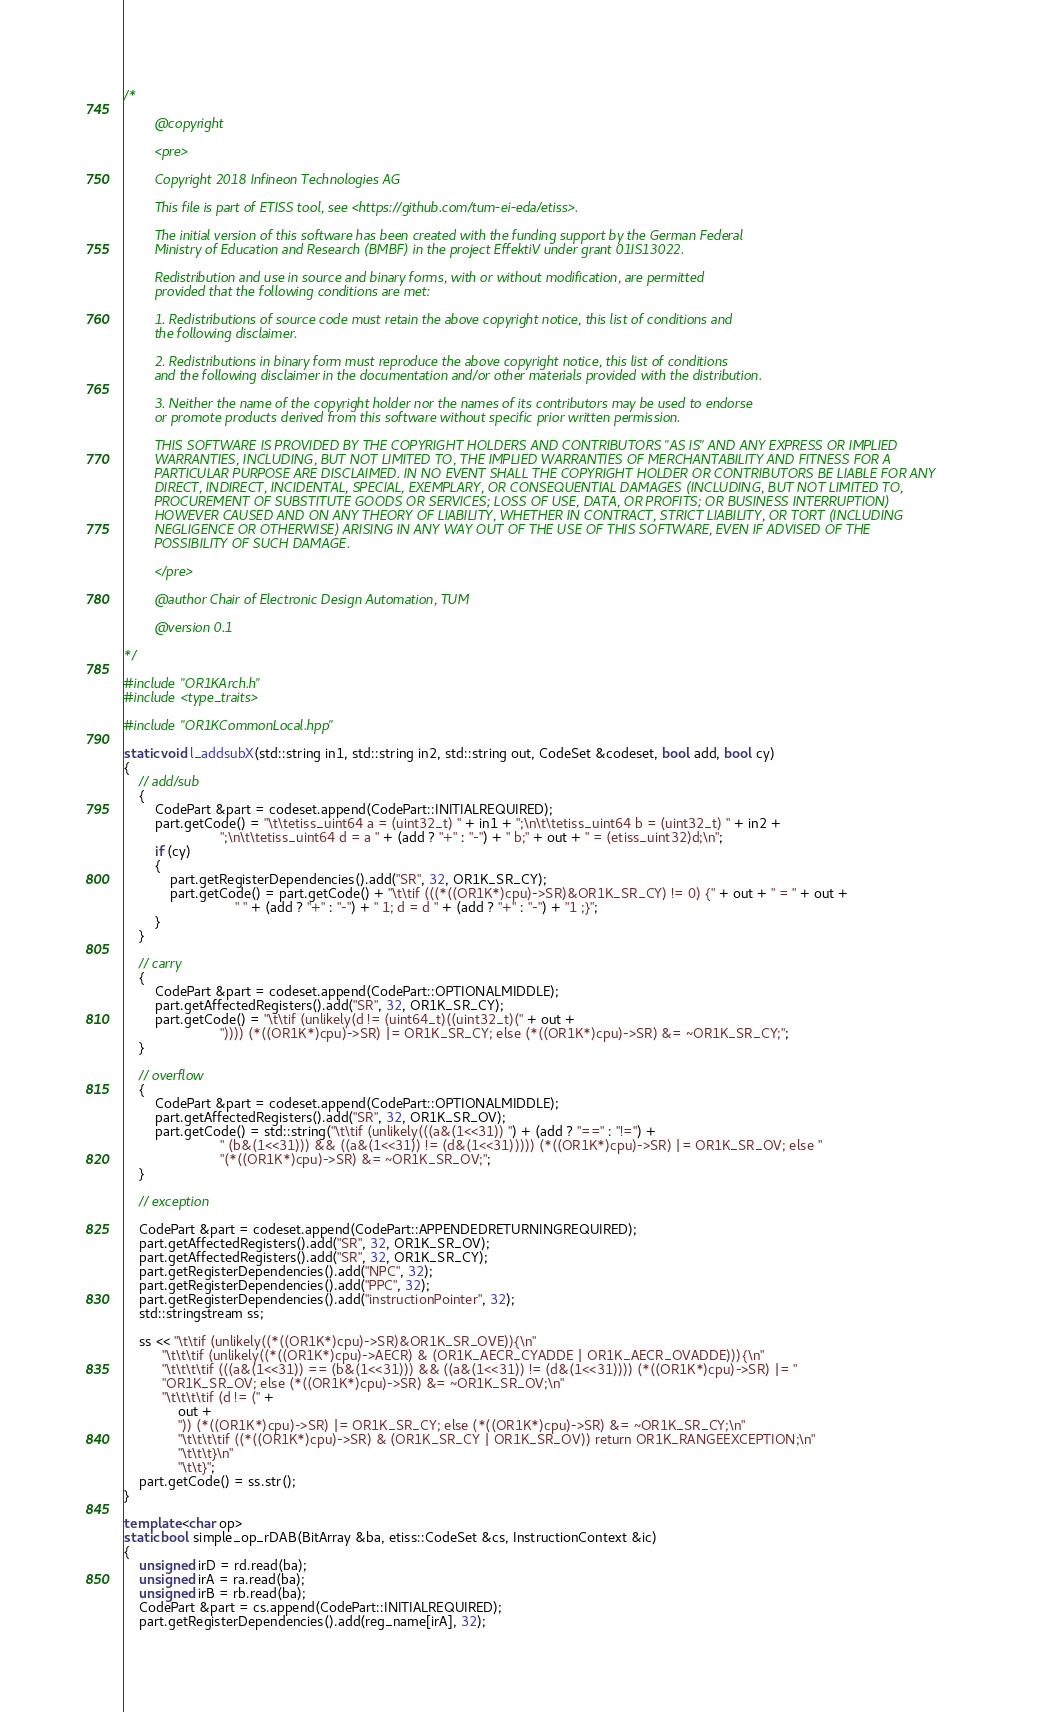Convert code to text. <code><loc_0><loc_0><loc_500><loc_500><_C++_>/*

        @copyright

        <pre>

        Copyright 2018 Infineon Technologies AG

        This file is part of ETISS tool, see <https://github.com/tum-ei-eda/etiss>.

        The initial version of this software has been created with the funding support by the German Federal
        Ministry of Education and Research (BMBF) in the project EffektiV under grant 01IS13022.

        Redistribution and use in source and binary forms, with or without modification, are permitted
        provided that the following conditions are met:

        1. Redistributions of source code must retain the above copyright notice, this list of conditions and
        the following disclaimer.

        2. Redistributions in binary form must reproduce the above copyright notice, this list of conditions
        and the following disclaimer in the documentation and/or other materials provided with the distribution.

        3. Neither the name of the copyright holder nor the names of its contributors may be used to endorse
        or promote products derived from this software without specific prior written permission.

        THIS SOFTWARE IS PROVIDED BY THE COPYRIGHT HOLDERS AND CONTRIBUTORS "AS IS" AND ANY EXPRESS OR IMPLIED
        WARRANTIES, INCLUDING, BUT NOT LIMITED TO, THE IMPLIED WARRANTIES OF MERCHANTABILITY AND FITNESS FOR A
        PARTICULAR PURPOSE ARE DISCLAIMED. IN NO EVENT SHALL THE COPYRIGHT HOLDER OR CONTRIBUTORS BE LIABLE FOR ANY
        DIRECT, INDIRECT, INCIDENTAL, SPECIAL, EXEMPLARY, OR CONSEQUENTIAL DAMAGES (INCLUDING, BUT NOT LIMITED TO,
        PROCUREMENT OF SUBSTITUTE GOODS OR SERVICES; LOSS OF USE, DATA, OR PROFITS; OR BUSINESS INTERRUPTION)
        HOWEVER CAUSED AND ON ANY THEORY OF LIABILITY, WHETHER IN CONTRACT, STRICT LIABILITY, OR TORT (INCLUDING
        NEGLIGENCE OR OTHERWISE) ARISING IN ANY WAY OUT OF THE USE OF THIS SOFTWARE, EVEN IF ADVISED OF THE
        POSSIBILITY OF SUCH DAMAGE.

        </pre>

        @author Chair of Electronic Design Automation, TUM

        @version 0.1

*/

#include "OR1KArch.h"
#include <type_traits>

#include "OR1KCommonLocal.hpp"

static void l_addsubX(std::string in1, std::string in2, std::string out, CodeSet &codeset, bool add, bool cy)
{
    // add/sub
    {
        CodePart &part = codeset.append(CodePart::INITIALREQUIRED);
        part.getCode() = "\t\tetiss_uint64 a = (uint32_t) " + in1 + ";\n\t\tetiss_uint64 b = (uint32_t) " + in2 +
                         ";\n\t\tetiss_uint64 d = a " + (add ? "+" : "-") + " b;" + out + " = (etiss_uint32)d;\n";
        if (cy)
        {
            part.getRegisterDependencies().add("SR", 32, OR1K_SR_CY);
            part.getCode() = part.getCode() + "\t\tif (((*((OR1K*)cpu)->SR)&OR1K_SR_CY) != 0) {" + out + " = " + out +
                             " " + (add ? "+" : "-") + " 1; d = d " + (add ? "+" : "-") + "1 ;}";
        }
    }

    // carry
    {
        CodePart &part = codeset.append(CodePart::OPTIONALMIDDLE);
        part.getAffectedRegisters().add("SR", 32, OR1K_SR_CY);
        part.getCode() = "\t\tif (unlikely(d != (uint64_t)((uint32_t)(" + out +
                         ")))) (*((OR1K*)cpu)->SR) |= OR1K_SR_CY; else (*((OR1K*)cpu)->SR) &= ~OR1K_SR_CY;";
    }

    // overflow
    {
        CodePart &part = codeset.append(CodePart::OPTIONALMIDDLE);
        part.getAffectedRegisters().add("SR", 32, OR1K_SR_OV);
        part.getCode() = std::string("\t\tif (unlikely(((a&(1<<31)) ") + (add ? "==" : "!=") +
                         " (b&(1<<31))) && ((a&(1<<31)) != (d&(1<<31))))) (*((OR1K*)cpu)->SR) |= OR1K_SR_OV; else "
                         "(*((OR1K*)cpu)->SR) &= ~OR1K_SR_OV;";
    }

    // exception

    CodePart &part = codeset.append(CodePart::APPENDEDRETURNINGREQUIRED);
    part.getAffectedRegisters().add("SR", 32, OR1K_SR_OV);
    part.getAffectedRegisters().add("SR", 32, OR1K_SR_CY);
    part.getRegisterDependencies().add("NPC", 32);
    part.getRegisterDependencies().add("PPC", 32);
    part.getRegisterDependencies().add("instructionPointer", 32);
    std::stringstream ss;

    ss << "\t\tif (unlikely((*((OR1K*)cpu)->SR)&OR1K_SR_OVE)){\n"
          "\t\t\tif (unlikely((*((OR1K*)cpu)->AECR) & (OR1K_AECR_CYADDE | OR1K_AECR_OVADDE))){\n"
          "\t\t\t\tif (((a&(1<<31)) == (b&(1<<31))) && ((a&(1<<31)) != (d&(1<<31)))) (*((OR1K*)cpu)->SR) |= "
          "OR1K_SR_OV; else (*((OR1K*)cpu)->SR) &= ~OR1K_SR_OV;\n"
          "\t\t\t\tif (d != (" +
              out +
              ")) (*((OR1K*)cpu)->SR) |= OR1K_SR_CY; else (*((OR1K*)cpu)->SR) &= ~OR1K_SR_CY;\n"
              "\t\t\t\tif ((*((OR1K*)cpu)->SR) & (OR1K_SR_CY | OR1K_SR_OV)) return OR1K_RANGEEXCEPTION;\n"
              "\t\t\t}\n"
              "\t\t}";
    part.getCode() = ss.str();
}

template <char op>
static bool simple_op_rDAB(BitArray &ba, etiss::CodeSet &cs, InstructionContext &ic)
{
    unsigned irD = rd.read(ba);
    unsigned irA = ra.read(ba);
    unsigned irB = rb.read(ba);
    CodePart &part = cs.append(CodePart::INITIALREQUIRED);
    part.getRegisterDependencies().add(reg_name[irA], 32);</code> 